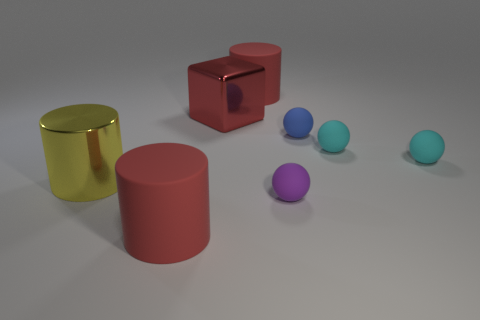Add 1 large red matte objects. How many objects exist? 9 Subtract all cylinders. How many objects are left? 5 Subtract 2 cyan balls. How many objects are left? 6 Subtract all big cubes. Subtract all red rubber cylinders. How many objects are left? 5 Add 4 cyan spheres. How many cyan spheres are left? 6 Add 6 purple objects. How many purple objects exist? 7 